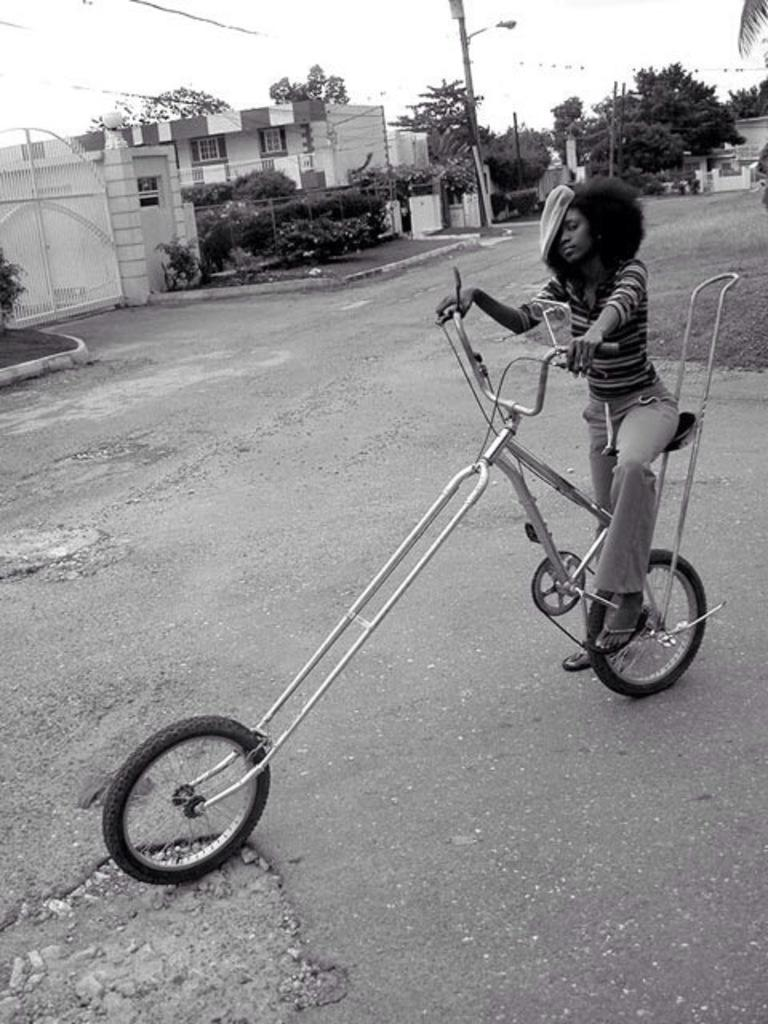Who is the main subject in the image? There is a girl in the image. What is the girl doing in the image? The girl is riding a bicycle. Where is the girl riding the bicycle? The bicycle is on a road. What can be seen in the background of the image? There is a building, a plant, a tree, and a street light in the background of the image. Can you tell me how many flowers are in the image? There are no flowers present in the image; it features a girl riding a bicycle on a road with a background that includes a building, a plant, a tree, and a street light. 